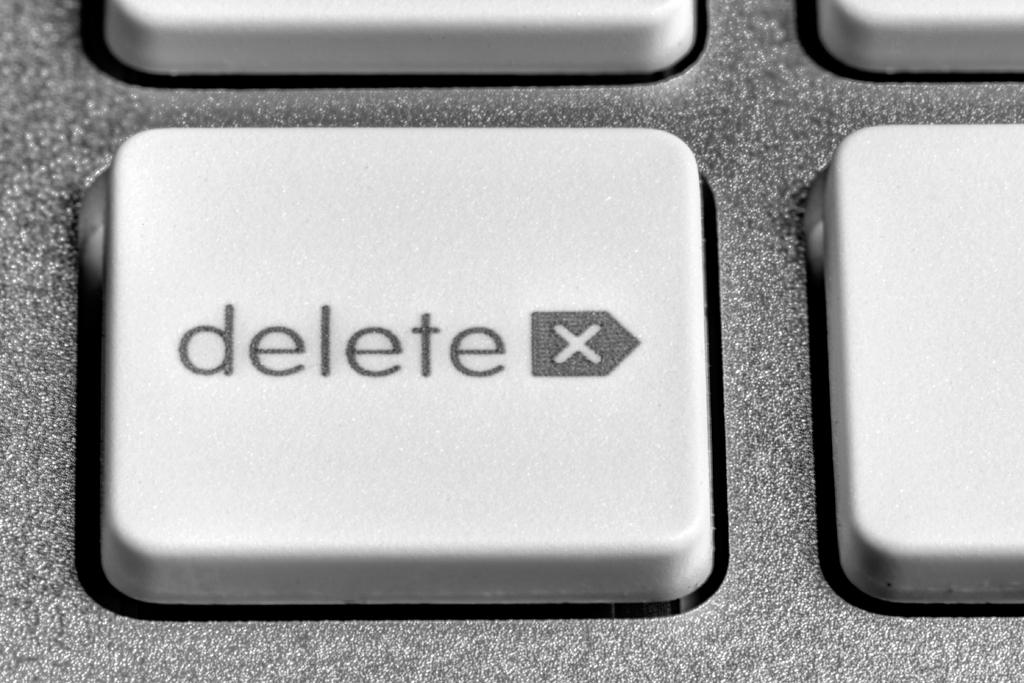<image>
Relay a brief, clear account of the picture shown. A close-up of a keyboard shows the delete key. 